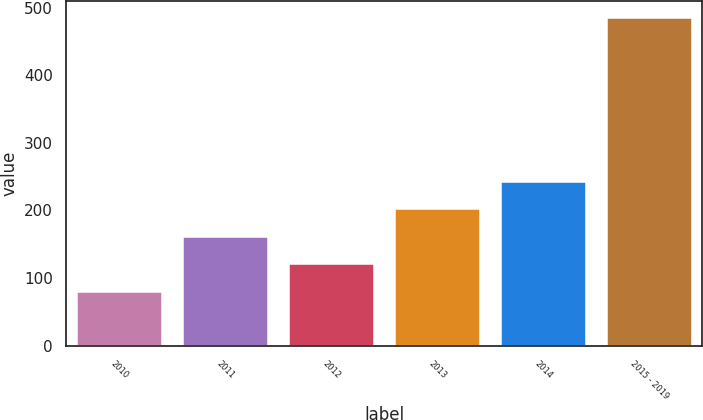<chart> <loc_0><loc_0><loc_500><loc_500><bar_chart><fcel>2010<fcel>2011<fcel>2012<fcel>2013<fcel>2014<fcel>2015 - 2019<nl><fcel>80<fcel>161<fcel>120.5<fcel>201.5<fcel>242<fcel>485<nl></chart> 